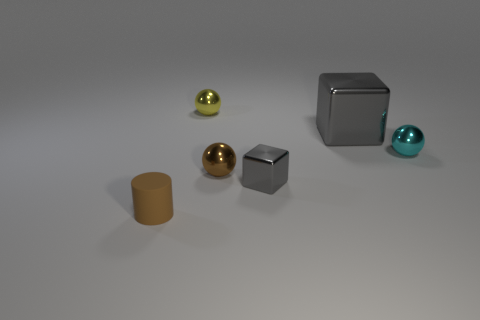Add 2 matte objects. How many objects exist? 8 Subtract all blocks. How many objects are left? 4 Add 6 tiny yellow metal spheres. How many tiny yellow metal spheres are left? 7 Add 4 metallic blocks. How many metallic blocks exist? 6 Subtract 0 gray balls. How many objects are left? 6 Subtract all brown things. Subtract all purple metallic cubes. How many objects are left? 4 